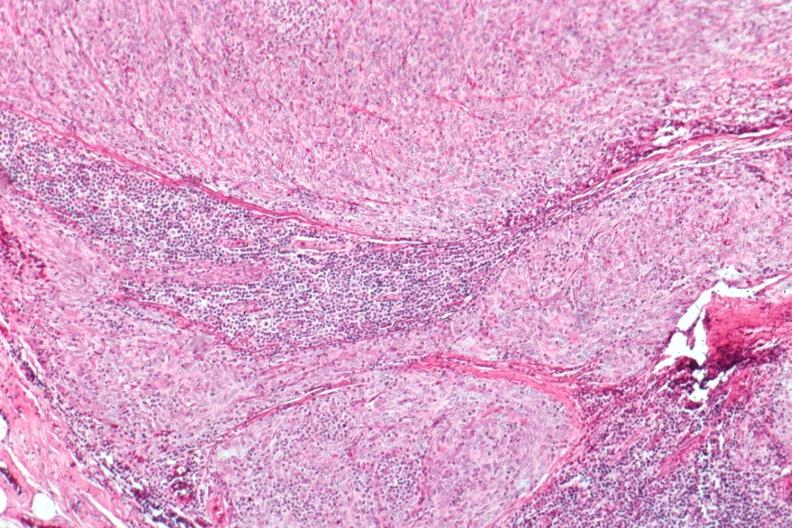s thymoma present?
Answer the question using a single word or phrase. Yes 